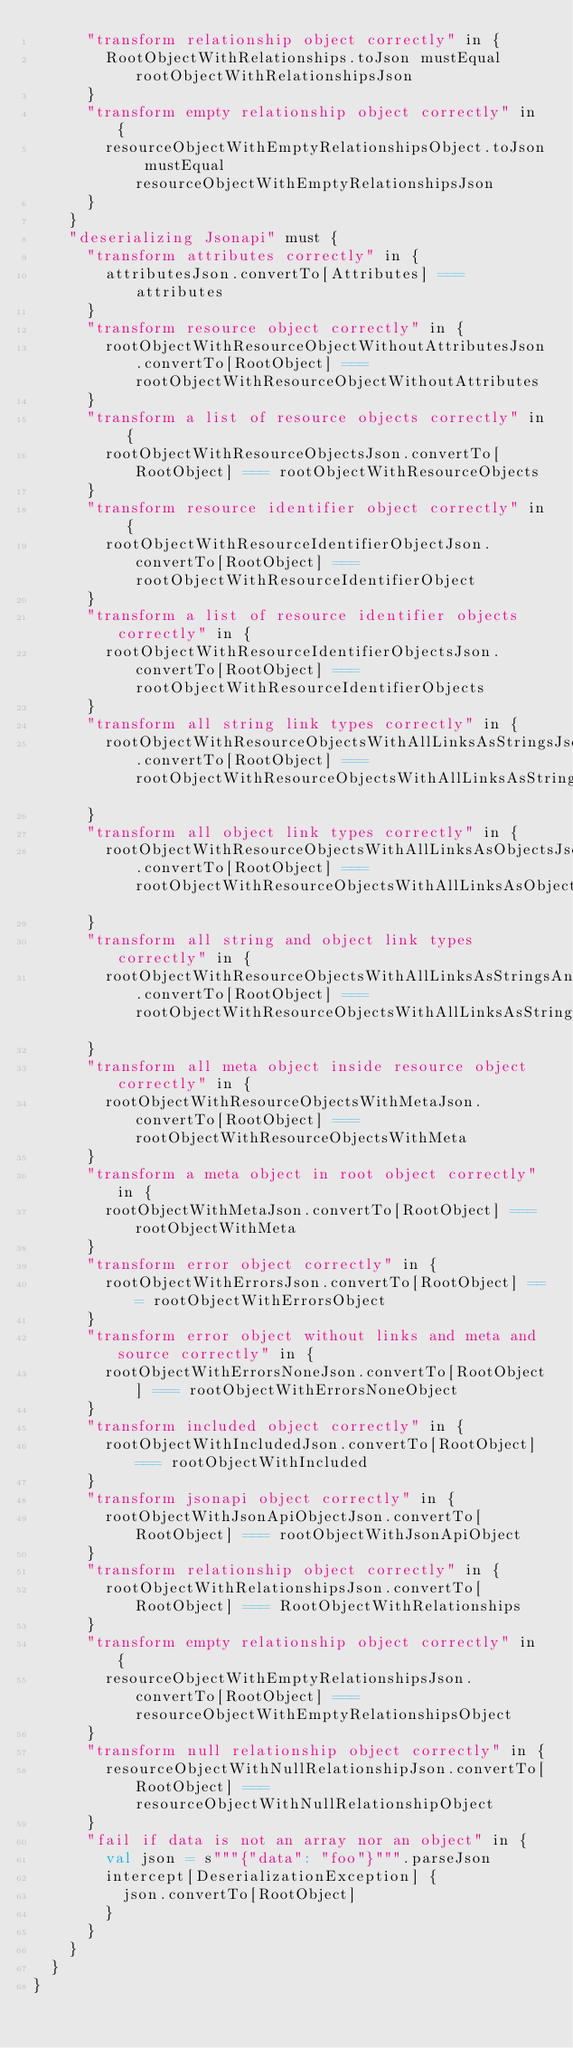<code> <loc_0><loc_0><loc_500><loc_500><_Scala_>      "transform relationship object correctly" in {
        RootObjectWithRelationships.toJson mustEqual rootObjectWithRelationshipsJson
      }
      "transform empty relationship object correctly" in {
        resourceObjectWithEmptyRelationshipsObject.toJson mustEqual resourceObjectWithEmptyRelationshipsJson
      }
    }
    "deserializing Jsonapi" must {
      "transform attributes correctly" in {
        attributesJson.convertTo[Attributes] === attributes
      }
      "transform resource object correctly" in {
        rootObjectWithResourceObjectWithoutAttributesJson.convertTo[RootObject] === rootObjectWithResourceObjectWithoutAttributes
      }
      "transform a list of resource objects correctly" in {
        rootObjectWithResourceObjectsJson.convertTo[RootObject] === rootObjectWithResourceObjects
      }
      "transform resource identifier object correctly" in {
        rootObjectWithResourceIdentifierObjectJson.convertTo[RootObject] === rootObjectWithResourceIdentifierObject
      }
      "transform a list of resource identifier objects correctly" in {
        rootObjectWithResourceIdentifierObjectsJson.convertTo[RootObject] === rootObjectWithResourceIdentifierObjects
      }
      "transform all string link types correctly" in {
        rootObjectWithResourceObjectsWithAllLinksAsStringsJson.convertTo[RootObject] === rootObjectWithResourceObjectsWithAllLinksAsStrings
      }
      "transform all object link types correctly" in {
        rootObjectWithResourceObjectsWithAllLinksAsObjectsJson.convertTo[RootObject] === rootObjectWithResourceObjectsWithAllLinksAsObjects
      }
      "transform all string and object link types correctly" in {
        rootObjectWithResourceObjectsWithAllLinksAsStringsAndObjectsJson.convertTo[RootObject] === rootObjectWithResourceObjectsWithAllLinksAsStringsAndObjects
      }
      "transform all meta object inside resource object correctly" in {
        rootObjectWithResourceObjectsWithMetaJson.convertTo[RootObject] === rootObjectWithResourceObjectsWithMeta
      }
      "transform a meta object in root object correctly" in {
        rootObjectWithMetaJson.convertTo[RootObject] === rootObjectWithMeta
      }
      "transform error object correctly" in {
        rootObjectWithErrorsJson.convertTo[RootObject] === rootObjectWithErrorsObject
      }
      "transform error object without links and meta and source correctly" in {
        rootObjectWithErrorsNoneJson.convertTo[RootObject] === rootObjectWithErrorsNoneObject
      }
      "transform included object correctly" in {
        rootObjectWithIncludedJson.convertTo[RootObject] === rootObjectWithIncluded
      }
      "transform jsonapi object correctly" in {
        rootObjectWithJsonApiObjectJson.convertTo[RootObject] === rootObjectWithJsonApiObject
      }
      "transform relationship object correctly" in {
        rootObjectWithRelationshipsJson.convertTo[RootObject] === RootObjectWithRelationships
      }
      "transform empty relationship object correctly" in {
        resourceObjectWithEmptyRelationshipsJson.convertTo[RootObject] === resourceObjectWithEmptyRelationshipsObject
      }
      "transform null relationship object correctly" in {
        resourceObjectWithNullRelationshipJson.convertTo[RootObject] === resourceObjectWithNullRelationshipObject
      }
      "fail if data is not an array nor an object" in {
        val json = s"""{"data": "foo"}""".parseJson
        intercept[DeserializationException] {
          json.convertTo[RootObject]
        }
      }
    }
  }
}</code> 